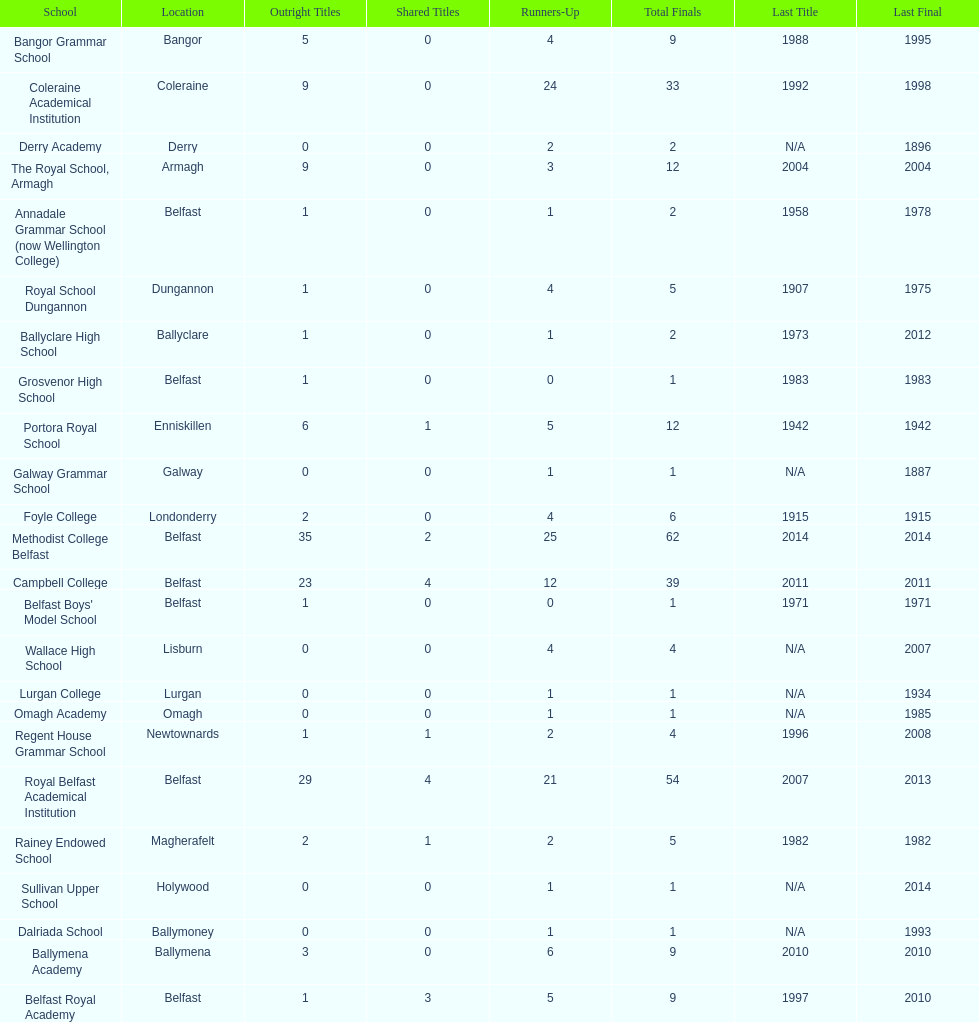Did belfast royal academy have more or less total finals than ballyclare high school? More. 